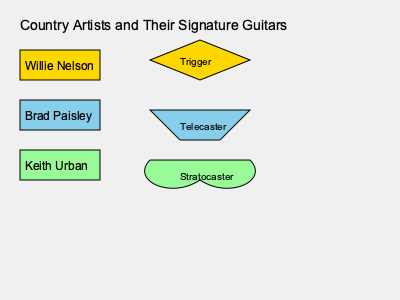Match the country music artists to their signature guitar shapes based on the information provided in the image. Which artist is associated with the guitar shape labeled "Trigger"? To answer this question, we need to analyze the information provided in the image:

1. The image shows three country music artists on the left side:
   - Willie Nelson (in gold)
   - Brad Paisley (in sky blue)
   - Keith Urban (in light green)

2. On the right side, we see three guitar shapes with labels:
   - A diamond-shaped guitar labeled "Trigger" (in gold)
   - A modified rectangle shape labeled "Telecaster" (in sky blue)
   - A curvy shape labeled "Stratocaster" (in light green)

3. The colors of the artists' names match the colors of the guitar shapes, indicating the associations:
   - Willie Nelson is associated with the gold-colored "Trigger" guitar
   - Brad Paisley is associated with the sky blue-colored "Telecaster" guitar
   - Keith Urban is associated with the light green-colored "Stratocaster" guitar

4. The question specifically asks about the guitar shape labeled "Trigger"

5. Based on the color-coding and labels, we can conclude that "Trigger" is associated with Willie Nelson.
Answer: Willie Nelson 